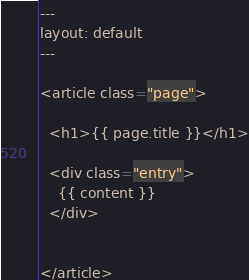Convert code to text. <code><loc_0><loc_0><loc_500><loc_500><_HTML_>---
layout: default
---

<article class="page">

  <h1>{{ page.title }}</h1>

  <div class="entry">
    {{ content }}
  </div>

 
</article>
</code> 